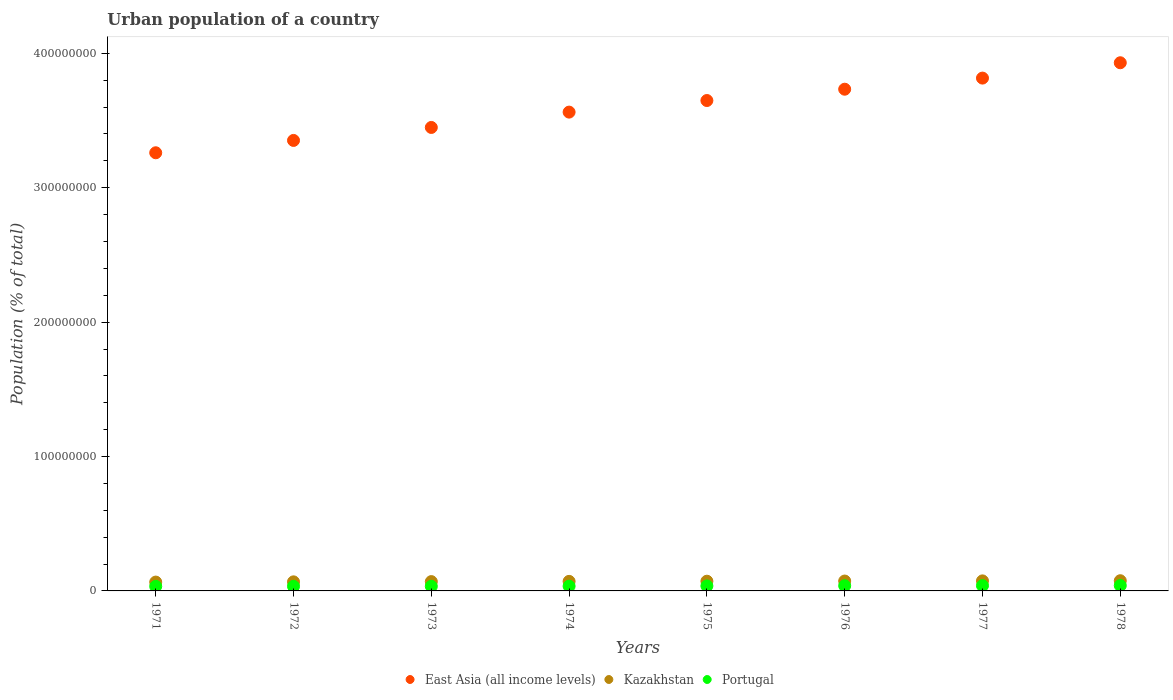How many different coloured dotlines are there?
Give a very brief answer. 3. Is the number of dotlines equal to the number of legend labels?
Your answer should be compact. Yes. What is the urban population in Kazakhstan in 1974?
Provide a succinct answer. 7.10e+06. Across all years, what is the maximum urban population in East Asia (all income levels)?
Provide a succinct answer. 3.93e+08. Across all years, what is the minimum urban population in East Asia (all income levels)?
Provide a short and direct response. 3.26e+08. In which year was the urban population in Kazakhstan maximum?
Offer a very short reply. 1978. In which year was the urban population in East Asia (all income levels) minimum?
Your answer should be compact. 1971. What is the total urban population in East Asia (all income levels) in the graph?
Your answer should be very brief. 2.88e+09. What is the difference between the urban population in Kazakhstan in 1973 and that in 1975?
Provide a succinct answer. -3.01e+05. What is the difference between the urban population in Kazakhstan in 1975 and the urban population in East Asia (all income levels) in 1977?
Make the answer very short. -3.74e+08. What is the average urban population in East Asia (all income levels) per year?
Provide a succinct answer. 3.59e+08. In the year 1972, what is the difference between the urban population in East Asia (all income levels) and urban population in Portugal?
Provide a succinct answer. 3.32e+08. In how many years, is the urban population in Kazakhstan greater than 180000000 %?
Keep it short and to the point. 0. What is the ratio of the urban population in Portugal in 1974 to that in 1976?
Your response must be concise. 0.92. Is the urban population in Portugal in 1974 less than that in 1977?
Provide a short and direct response. Yes. Is the difference between the urban population in East Asia (all income levels) in 1975 and 1977 greater than the difference between the urban population in Portugal in 1975 and 1977?
Your response must be concise. No. What is the difference between the highest and the second highest urban population in Portugal?
Your response must be concise. 8.10e+04. What is the difference between the highest and the lowest urban population in Portugal?
Provide a short and direct response. 6.24e+05. In how many years, is the urban population in East Asia (all income levels) greater than the average urban population in East Asia (all income levels) taken over all years?
Offer a very short reply. 4. Is the sum of the urban population in East Asia (all income levels) in 1972 and 1976 greater than the maximum urban population in Portugal across all years?
Provide a succinct answer. Yes. Does the urban population in Kazakhstan monotonically increase over the years?
Give a very brief answer. Yes. Is the urban population in East Asia (all income levels) strictly less than the urban population in Portugal over the years?
Your answer should be very brief. No. How many dotlines are there?
Give a very brief answer. 3. Are the values on the major ticks of Y-axis written in scientific E-notation?
Your answer should be very brief. No. Does the graph contain any zero values?
Offer a very short reply. No. Where does the legend appear in the graph?
Your answer should be very brief. Bottom center. How many legend labels are there?
Offer a very short reply. 3. How are the legend labels stacked?
Provide a succinct answer. Horizontal. What is the title of the graph?
Keep it short and to the point. Urban population of a country. What is the label or title of the Y-axis?
Keep it short and to the point. Population (% of total). What is the Population (% of total) of East Asia (all income levels) in 1971?
Your response must be concise. 3.26e+08. What is the Population (% of total) of Kazakhstan in 1971?
Make the answer very short. 6.58e+06. What is the Population (% of total) in Portugal in 1971?
Provide a succinct answer. 3.39e+06. What is the Population (% of total) of East Asia (all income levels) in 1972?
Your answer should be very brief. 3.35e+08. What is the Population (% of total) of Kazakhstan in 1972?
Make the answer very short. 6.76e+06. What is the Population (% of total) of Portugal in 1972?
Make the answer very short. 3.42e+06. What is the Population (% of total) of East Asia (all income levels) in 1973?
Your answer should be very brief. 3.45e+08. What is the Population (% of total) of Kazakhstan in 1973?
Offer a very short reply. 6.93e+06. What is the Population (% of total) of Portugal in 1973?
Make the answer very short. 3.45e+06. What is the Population (% of total) of East Asia (all income levels) in 1974?
Ensure brevity in your answer.  3.56e+08. What is the Population (% of total) in Kazakhstan in 1974?
Your answer should be compact. 7.10e+06. What is the Population (% of total) of Portugal in 1974?
Your response must be concise. 3.54e+06. What is the Population (% of total) of East Asia (all income levels) in 1975?
Your answer should be compact. 3.65e+08. What is the Population (% of total) of Kazakhstan in 1975?
Your answer should be very brief. 7.23e+06. What is the Population (% of total) of Portugal in 1975?
Provide a succinct answer. 3.71e+06. What is the Population (% of total) in East Asia (all income levels) in 1976?
Your answer should be very brief. 3.73e+08. What is the Population (% of total) in Kazakhstan in 1976?
Your answer should be compact. 7.35e+06. What is the Population (% of total) of Portugal in 1976?
Your response must be concise. 3.85e+06. What is the Population (% of total) of East Asia (all income levels) in 1977?
Give a very brief answer. 3.82e+08. What is the Population (% of total) of Kazakhstan in 1977?
Keep it short and to the point. 7.47e+06. What is the Population (% of total) of Portugal in 1977?
Offer a very short reply. 3.93e+06. What is the Population (% of total) in East Asia (all income levels) in 1978?
Your answer should be very brief. 3.93e+08. What is the Population (% of total) of Kazakhstan in 1978?
Make the answer very short. 7.58e+06. What is the Population (% of total) in Portugal in 1978?
Your answer should be very brief. 4.01e+06. Across all years, what is the maximum Population (% of total) in East Asia (all income levels)?
Offer a very short reply. 3.93e+08. Across all years, what is the maximum Population (% of total) of Kazakhstan?
Provide a short and direct response. 7.58e+06. Across all years, what is the maximum Population (% of total) in Portugal?
Give a very brief answer. 4.01e+06. Across all years, what is the minimum Population (% of total) of East Asia (all income levels)?
Ensure brevity in your answer.  3.26e+08. Across all years, what is the minimum Population (% of total) in Kazakhstan?
Offer a terse response. 6.58e+06. Across all years, what is the minimum Population (% of total) in Portugal?
Give a very brief answer. 3.39e+06. What is the total Population (% of total) of East Asia (all income levels) in the graph?
Give a very brief answer. 2.88e+09. What is the total Population (% of total) in Kazakhstan in the graph?
Provide a succinct answer. 5.70e+07. What is the total Population (% of total) in Portugal in the graph?
Your response must be concise. 2.93e+07. What is the difference between the Population (% of total) in East Asia (all income levels) in 1971 and that in 1972?
Give a very brief answer. -9.18e+06. What is the difference between the Population (% of total) in Kazakhstan in 1971 and that in 1972?
Your answer should be very brief. -1.74e+05. What is the difference between the Population (% of total) of Portugal in 1971 and that in 1972?
Ensure brevity in your answer.  -2.88e+04. What is the difference between the Population (% of total) in East Asia (all income levels) in 1971 and that in 1973?
Your answer should be compact. -1.88e+07. What is the difference between the Population (% of total) in Kazakhstan in 1971 and that in 1973?
Your answer should be compact. -3.49e+05. What is the difference between the Population (% of total) of Portugal in 1971 and that in 1973?
Provide a succinct answer. -6.39e+04. What is the difference between the Population (% of total) in East Asia (all income levels) in 1971 and that in 1974?
Your answer should be compact. -3.03e+07. What is the difference between the Population (% of total) in Kazakhstan in 1971 and that in 1974?
Your answer should be very brief. -5.20e+05. What is the difference between the Population (% of total) in Portugal in 1971 and that in 1974?
Your answer should be compact. -1.47e+05. What is the difference between the Population (% of total) in East Asia (all income levels) in 1971 and that in 1975?
Make the answer very short. -3.89e+07. What is the difference between the Population (% of total) of Kazakhstan in 1971 and that in 1975?
Your answer should be very brief. -6.50e+05. What is the difference between the Population (% of total) in Portugal in 1971 and that in 1975?
Provide a short and direct response. -3.20e+05. What is the difference between the Population (% of total) in East Asia (all income levels) in 1971 and that in 1976?
Your answer should be very brief. -4.73e+07. What is the difference between the Population (% of total) in Kazakhstan in 1971 and that in 1976?
Provide a succinct answer. -7.73e+05. What is the difference between the Population (% of total) in Portugal in 1971 and that in 1976?
Your answer should be compact. -4.65e+05. What is the difference between the Population (% of total) in East Asia (all income levels) in 1971 and that in 1977?
Give a very brief answer. -5.56e+07. What is the difference between the Population (% of total) in Kazakhstan in 1971 and that in 1977?
Make the answer very short. -8.89e+05. What is the difference between the Population (% of total) of Portugal in 1971 and that in 1977?
Provide a succinct answer. -5.43e+05. What is the difference between the Population (% of total) in East Asia (all income levels) in 1971 and that in 1978?
Your answer should be very brief. -6.70e+07. What is the difference between the Population (% of total) of Kazakhstan in 1971 and that in 1978?
Offer a very short reply. -1.00e+06. What is the difference between the Population (% of total) of Portugal in 1971 and that in 1978?
Ensure brevity in your answer.  -6.24e+05. What is the difference between the Population (% of total) of East Asia (all income levels) in 1972 and that in 1973?
Keep it short and to the point. -9.66e+06. What is the difference between the Population (% of total) of Kazakhstan in 1972 and that in 1973?
Your answer should be very brief. -1.74e+05. What is the difference between the Population (% of total) in Portugal in 1972 and that in 1973?
Keep it short and to the point. -3.51e+04. What is the difference between the Population (% of total) of East Asia (all income levels) in 1972 and that in 1974?
Offer a terse response. -2.11e+07. What is the difference between the Population (% of total) of Kazakhstan in 1972 and that in 1974?
Make the answer very short. -3.45e+05. What is the difference between the Population (% of total) of Portugal in 1972 and that in 1974?
Provide a short and direct response. -1.18e+05. What is the difference between the Population (% of total) of East Asia (all income levels) in 1972 and that in 1975?
Make the answer very short. -2.97e+07. What is the difference between the Population (% of total) of Kazakhstan in 1972 and that in 1975?
Offer a very short reply. -4.76e+05. What is the difference between the Population (% of total) of Portugal in 1972 and that in 1975?
Provide a short and direct response. -2.91e+05. What is the difference between the Population (% of total) of East Asia (all income levels) in 1972 and that in 1976?
Make the answer very short. -3.81e+07. What is the difference between the Population (% of total) in Kazakhstan in 1972 and that in 1976?
Keep it short and to the point. -5.98e+05. What is the difference between the Population (% of total) of Portugal in 1972 and that in 1976?
Offer a terse response. -4.36e+05. What is the difference between the Population (% of total) in East Asia (all income levels) in 1972 and that in 1977?
Your answer should be compact. -4.64e+07. What is the difference between the Population (% of total) of Kazakhstan in 1972 and that in 1977?
Make the answer very short. -7.15e+05. What is the difference between the Population (% of total) of Portugal in 1972 and that in 1977?
Ensure brevity in your answer.  -5.15e+05. What is the difference between the Population (% of total) in East Asia (all income levels) in 1972 and that in 1978?
Give a very brief answer. -5.78e+07. What is the difference between the Population (% of total) in Kazakhstan in 1972 and that in 1978?
Your response must be concise. -8.29e+05. What is the difference between the Population (% of total) of Portugal in 1972 and that in 1978?
Provide a short and direct response. -5.96e+05. What is the difference between the Population (% of total) in East Asia (all income levels) in 1973 and that in 1974?
Provide a succinct answer. -1.14e+07. What is the difference between the Population (% of total) in Kazakhstan in 1973 and that in 1974?
Offer a terse response. -1.71e+05. What is the difference between the Population (% of total) in Portugal in 1973 and that in 1974?
Your response must be concise. -8.32e+04. What is the difference between the Population (% of total) of East Asia (all income levels) in 1973 and that in 1975?
Your response must be concise. -2.00e+07. What is the difference between the Population (% of total) of Kazakhstan in 1973 and that in 1975?
Your response must be concise. -3.01e+05. What is the difference between the Population (% of total) of Portugal in 1973 and that in 1975?
Provide a succinct answer. -2.56e+05. What is the difference between the Population (% of total) in East Asia (all income levels) in 1973 and that in 1976?
Provide a succinct answer. -2.85e+07. What is the difference between the Population (% of total) of Kazakhstan in 1973 and that in 1976?
Give a very brief answer. -4.24e+05. What is the difference between the Population (% of total) of Portugal in 1973 and that in 1976?
Make the answer very short. -4.01e+05. What is the difference between the Population (% of total) in East Asia (all income levels) in 1973 and that in 1977?
Your answer should be very brief. -3.67e+07. What is the difference between the Population (% of total) in Kazakhstan in 1973 and that in 1977?
Offer a terse response. -5.40e+05. What is the difference between the Population (% of total) of Portugal in 1973 and that in 1977?
Your answer should be very brief. -4.80e+05. What is the difference between the Population (% of total) in East Asia (all income levels) in 1973 and that in 1978?
Your response must be concise. -4.81e+07. What is the difference between the Population (% of total) in Kazakhstan in 1973 and that in 1978?
Give a very brief answer. -6.55e+05. What is the difference between the Population (% of total) in Portugal in 1973 and that in 1978?
Your answer should be compact. -5.61e+05. What is the difference between the Population (% of total) in East Asia (all income levels) in 1974 and that in 1975?
Offer a terse response. -8.62e+06. What is the difference between the Population (% of total) in Kazakhstan in 1974 and that in 1975?
Offer a terse response. -1.30e+05. What is the difference between the Population (% of total) of Portugal in 1974 and that in 1975?
Keep it short and to the point. -1.73e+05. What is the difference between the Population (% of total) in East Asia (all income levels) in 1974 and that in 1976?
Your answer should be very brief. -1.70e+07. What is the difference between the Population (% of total) of Kazakhstan in 1974 and that in 1976?
Offer a very short reply. -2.53e+05. What is the difference between the Population (% of total) in Portugal in 1974 and that in 1976?
Ensure brevity in your answer.  -3.17e+05. What is the difference between the Population (% of total) in East Asia (all income levels) in 1974 and that in 1977?
Your response must be concise. -2.53e+07. What is the difference between the Population (% of total) of Kazakhstan in 1974 and that in 1977?
Ensure brevity in your answer.  -3.70e+05. What is the difference between the Population (% of total) in Portugal in 1974 and that in 1977?
Provide a short and direct response. -3.96e+05. What is the difference between the Population (% of total) in East Asia (all income levels) in 1974 and that in 1978?
Give a very brief answer. -3.67e+07. What is the difference between the Population (% of total) in Kazakhstan in 1974 and that in 1978?
Offer a terse response. -4.84e+05. What is the difference between the Population (% of total) in Portugal in 1974 and that in 1978?
Offer a very short reply. -4.77e+05. What is the difference between the Population (% of total) in East Asia (all income levels) in 1975 and that in 1976?
Ensure brevity in your answer.  -8.42e+06. What is the difference between the Population (% of total) of Kazakhstan in 1975 and that in 1976?
Your answer should be compact. -1.23e+05. What is the difference between the Population (% of total) of Portugal in 1975 and that in 1976?
Ensure brevity in your answer.  -1.44e+05. What is the difference between the Population (% of total) in East Asia (all income levels) in 1975 and that in 1977?
Provide a succinct answer. -1.67e+07. What is the difference between the Population (% of total) of Kazakhstan in 1975 and that in 1977?
Offer a very short reply. -2.39e+05. What is the difference between the Population (% of total) in Portugal in 1975 and that in 1977?
Offer a terse response. -2.23e+05. What is the difference between the Population (% of total) in East Asia (all income levels) in 1975 and that in 1978?
Ensure brevity in your answer.  -2.81e+07. What is the difference between the Population (% of total) in Kazakhstan in 1975 and that in 1978?
Your response must be concise. -3.53e+05. What is the difference between the Population (% of total) in Portugal in 1975 and that in 1978?
Your answer should be compact. -3.04e+05. What is the difference between the Population (% of total) in East Asia (all income levels) in 1976 and that in 1977?
Ensure brevity in your answer.  -8.27e+06. What is the difference between the Population (% of total) in Kazakhstan in 1976 and that in 1977?
Keep it short and to the point. -1.17e+05. What is the difference between the Population (% of total) of Portugal in 1976 and that in 1977?
Make the answer very short. -7.89e+04. What is the difference between the Population (% of total) of East Asia (all income levels) in 1976 and that in 1978?
Ensure brevity in your answer.  -1.97e+07. What is the difference between the Population (% of total) of Kazakhstan in 1976 and that in 1978?
Keep it short and to the point. -2.31e+05. What is the difference between the Population (% of total) of Portugal in 1976 and that in 1978?
Provide a succinct answer. -1.60e+05. What is the difference between the Population (% of total) of East Asia (all income levels) in 1977 and that in 1978?
Ensure brevity in your answer.  -1.14e+07. What is the difference between the Population (% of total) of Kazakhstan in 1977 and that in 1978?
Provide a short and direct response. -1.14e+05. What is the difference between the Population (% of total) of Portugal in 1977 and that in 1978?
Your answer should be very brief. -8.10e+04. What is the difference between the Population (% of total) of East Asia (all income levels) in 1971 and the Population (% of total) of Kazakhstan in 1972?
Offer a terse response. 3.19e+08. What is the difference between the Population (% of total) in East Asia (all income levels) in 1971 and the Population (% of total) in Portugal in 1972?
Offer a very short reply. 3.23e+08. What is the difference between the Population (% of total) in Kazakhstan in 1971 and the Population (% of total) in Portugal in 1972?
Your response must be concise. 3.16e+06. What is the difference between the Population (% of total) of East Asia (all income levels) in 1971 and the Population (% of total) of Kazakhstan in 1973?
Keep it short and to the point. 3.19e+08. What is the difference between the Population (% of total) in East Asia (all income levels) in 1971 and the Population (% of total) in Portugal in 1973?
Your answer should be very brief. 3.23e+08. What is the difference between the Population (% of total) in Kazakhstan in 1971 and the Population (% of total) in Portugal in 1973?
Your answer should be very brief. 3.13e+06. What is the difference between the Population (% of total) in East Asia (all income levels) in 1971 and the Population (% of total) in Kazakhstan in 1974?
Provide a short and direct response. 3.19e+08. What is the difference between the Population (% of total) of East Asia (all income levels) in 1971 and the Population (% of total) of Portugal in 1974?
Make the answer very short. 3.22e+08. What is the difference between the Population (% of total) of Kazakhstan in 1971 and the Population (% of total) of Portugal in 1974?
Your answer should be compact. 3.05e+06. What is the difference between the Population (% of total) in East Asia (all income levels) in 1971 and the Population (% of total) in Kazakhstan in 1975?
Offer a terse response. 3.19e+08. What is the difference between the Population (% of total) of East Asia (all income levels) in 1971 and the Population (% of total) of Portugal in 1975?
Ensure brevity in your answer.  3.22e+08. What is the difference between the Population (% of total) of Kazakhstan in 1971 and the Population (% of total) of Portugal in 1975?
Your answer should be compact. 2.87e+06. What is the difference between the Population (% of total) of East Asia (all income levels) in 1971 and the Population (% of total) of Kazakhstan in 1976?
Your answer should be compact. 3.19e+08. What is the difference between the Population (% of total) of East Asia (all income levels) in 1971 and the Population (% of total) of Portugal in 1976?
Make the answer very short. 3.22e+08. What is the difference between the Population (% of total) in Kazakhstan in 1971 and the Population (% of total) in Portugal in 1976?
Make the answer very short. 2.73e+06. What is the difference between the Population (% of total) in East Asia (all income levels) in 1971 and the Population (% of total) in Kazakhstan in 1977?
Offer a very short reply. 3.19e+08. What is the difference between the Population (% of total) of East Asia (all income levels) in 1971 and the Population (% of total) of Portugal in 1977?
Make the answer very short. 3.22e+08. What is the difference between the Population (% of total) in Kazakhstan in 1971 and the Population (% of total) in Portugal in 1977?
Keep it short and to the point. 2.65e+06. What is the difference between the Population (% of total) in East Asia (all income levels) in 1971 and the Population (% of total) in Kazakhstan in 1978?
Give a very brief answer. 3.18e+08. What is the difference between the Population (% of total) of East Asia (all income levels) in 1971 and the Population (% of total) of Portugal in 1978?
Make the answer very short. 3.22e+08. What is the difference between the Population (% of total) of Kazakhstan in 1971 and the Population (% of total) of Portugal in 1978?
Provide a succinct answer. 2.57e+06. What is the difference between the Population (% of total) in East Asia (all income levels) in 1972 and the Population (% of total) in Kazakhstan in 1973?
Your response must be concise. 3.28e+08. What is the difference between the Population (% of total) in East Asia (all income levels) in 1972 and the Population (% of total) in Portugal in 1973?
Make the answer very short. 3.32e+08. What is the difference between the Population (% of total) in Kazakhstan in 1972 and the Population (% of total) in Portugal in 1973?
Keep it short and to the point. 3.30e+06. What is the difference between the Population (% of total) of East Asia (all income levels) in 1972 and the Population (% of total) of Kazakhstan in 1974?
Give a very brief answer. 3.28e+08. What is the difference between the Population (% of total) in East Asia (all income levels) in 1972 and the Population (% of total) in Portugal in 1974?
Provide a succinct answer. 3.32e+08. What is the difference between the Population (% of total) in Kazakhstan in 1972 and the Population (% of total) in Portugal in 1974?
Offer a terse response. 3.22e+06. What is the difference between the Population (% of total) in East Asia (all income levels) in 1972 and the Population (% of total) in Kazakhstan in 1975?
Provide a short and direct response. 3.28e+08. What is the difference between the Population (% of total) of East Asia (all income levels) in 1972 and the Population (% of total) of Portugal in 1975?
Offer a very short reply. 3.31e+08. What is the difference between the Population (% of total) in Kazakhstan in 1972 and the Population (% of total) in Portugal in 1975?
Your response must be concise. 3.05e+06. What is the difference between the Population (% of total) in East Asia (all income levels) in 1972 and the Population (% of total) in Kazakhstan in 1976?
Ensure brevity in your answer.  3.28e+08. What is the difference between the Population (% of total) in East Asia (all income levels) in 1972 and the Population (% of total) in Portugal in 1976?
Provide a short and direct response. 3.31e+08. What is the difference between the Population (% of total) in Kazakhstan in 1972 and the Population (% of total) in Portugal in 1976?
Your answer should be very brief. 2.90e+06. What is the difference between the Population (% of total) of East Asia (all income levels) in 1972 and the Population (% of total) of Kazakhstan in 1977?
Your answer should be very brief. 3.28e+08. What is the difference between the Population (% of total) of East Asia (all income levels) in 1972 and the Population (% of total) of Portugal in 1977?
Keep it short and to the point. 3.31e+08. What is the difference between the Population (% of total) of Kazakhstan in 1972 and the Population (% of total) of Portugal in 1977?
Provide a succinct answer. 2.82e+06. What is the difference between the Population (% of total) of East Asia (all income levels) in 1972 and the Population (% of total) of Kazakhstan in 1978?
Offer a very short reply. 3.28e+08. What is the difference between the Population (% of total) of East Asia (all income levels) in 1972 and the Population (% of total) of Portugal in 1978?
Provide a succinct answer. 3.31e+08. What is the difference between the Population (% of total) of Kazakhstan in 1972 and the Population (% of total) of Portugal in 1978?
Make the answer very short. 2.74e+06. What is the difference between the Population (% of total) of East Asia (all income levels) in 1973 and the Population (% of total) of Kazakhstan in 1974?
Make the answer very short. 3.38e+08. What is the difference between the Population (% of total) of East Asia (all income levels) in 1973 and the Population (% of total) of Portugal in 1974?
Offer a terse response. 3.41e+08. What is the difference between the Population (% of total) in Kazakhstan in 1973 and the Population (% of total) in Portugal in 1974?
Ensure brevity in your answer.  3.39e+06. What is the difference between the Population (% of total) in East Asia (all income levels) in 1973 and the Population (% of total) in Kazakhstan in 1975?
Keep it short and to the point. 3.38e+08. What is the difference between the Population (% of total) of East Asia (all income levels) in 1973 and the Population (% of total) of Portugal in 1975?
Keep it short and to the point. 3.41e+08. What is the difference between the Population (% of total) in Kazakhstan in 1973 and the Population (% of total) in Portugal in 1975?
Ensure brevity in your answer.  3.22e+06. What is the difference between the Population (% of total) in East Asia (all income levels) in 1973 and the Population (% of total) in Kazakhstan in 1976?
Your answer should be very brief. 3.38e+08. What is the difference between the Population (% of total) of East Asia (all income levels) in 1973 and the Population (% of total) of Portugal in 1976?
Your answer should be compact. 3.41e+08. What is the difference between the Population (% of total) of Kazakhstan in 1973 and the Population (% of total) of Portugal in 1976?
Ensure brevity in your answer.  3.08e+06. What is the difference between the Population (% of total) of East Asia (all income levels) in 1973 and the Population (% of total) of Kazakhstan in 1977?
Make the answer very short. 3.37e+08. What is the difference between the Population (% of total) in East Asia (all income levels) in 1973 and the Population (% of total) in Portugal in 1977?
Your response must be concise. 3.41e+08. What is the difference between the Population (% of total) in Kazakhstan in 1973 and the Population (% of total) in Portugal in 1977?
Offer a very short reply. 3.00e+06. What is the difference between the Population (% of total) of East Asia (all income levels) in 1973 and the Population (% of total) of Kazakhstan in 1978?
Provide a short and direct response. 3.37e+08. What is the difference between the Population (% of total) in East Asia (all income levels) in 1973 and the Population (% of total) in Portugal in 1978?
Your answer should be very brief. 3.41e+08. What is the difference between the Population (% of total) of Kazakhstan in 1973 and the Population (% of total) of Portugal in 1978?
Provide a short and direct response. 2.92e+06. What is the difference between the Population (% of total) in East Asia (all income levels) in 1974 and the Population (% of total) in Kazakhstan in 1975?
Provide a succinct answer. 3.49e+08. What is the difference between the Population (% of total) in East Asia (all income levels) in 1974 and the Population (% of total) in Portugal in 1975?
Make the answer very short. 3.53e+08. What is the difference between the Population (% of total) in Kazakhstan in 1974 and the Population (% of total) in Portugal in 1975?
Offer a very short reply. 3.39e+06. What is the difference between the Population (% of total) of East Asia (all income levels) in 1974 and the Population (% of total) of Kazakhstan in 1976?
Provide a succinct answer. 3.49e+08. What is the difference between the Population (% of total) of East Asia (all income levels) in 1974 and the Population (% of total) of Portugal in 1976?
Make the answer very short. 3.52e+08. What is the difference between the Population (% of total) of Kazakhstan in 1974 and the Population (% of total) of Portugal in 1976?
Your answer should be compact. 3.25e+06. What is the difference between the Population (% of total) of East Asia (all income levels) in 1974 and the Population (% of total) of Kazakhstan in 1977?
Your answer should be very brief. 3.49e+08. What is the difference between the Population (% of total) of East Asia (all income levels) in 1974 and the Population (% of total) of Portugal in 1977?
Provide a succinct answer. 3.52e+08. What is the difference between the Population (% of total) of Kazakhstan in 1974 and the Population (% of total) of Portugal in 1977?
Provide a succinct answer. 3.17e+06. What is the difference between the Population (% of total) in East Asia (all income levels) in 1974 and the Population (% of total) in Kazakhstan in 1978?
Provide a short and direct response. 3.49e+08. What is the difference between the Population (% of total) in East Asia (all income levels) in 1974 and the Population (% of total) in Portugal in 1978?
Your response must be concise. 3.52e+08. What is the difference between the Population (% of total) in Kazakhstan in 1974 and the Population (% of total) in Portugal in 1978?
Offer a terse response. 3.09e+06. What is the difference between the Population (% of total) in East Asia (all income levels) in 1975 and the Population (% of total) in Kazakhstan in 1976?
Your answer should be compact. 3.58e+08. What is the difference between the Population (% of total) in East Asia (all income levels) in 1975 and the Population (% of total) in Portugal in 1976?
Give a very brief answer. 3.61e+08. What is the difference between the Population (% of total) of Kazakhstan in 1975 and the Population (% of total) of Portugal in 1976?
Your answer should be very brief. 3.38e+06. What is the difference between the Population (% of total) of East Asia (all income levels) in 1975 and the Population (% of total) of Kazakhstan in 1977?
Your response must be concise. 3.57e+08. What is the difference between the Population (% of total) in East Asia (all income levels) in 1975 and the Population (% of total) in Portugal in 1977?
Give a very brief answer. 3.61e+08. What is the difference between the Population (% of total) of Kazakhstan in 1975 and the Population (% of total) of Portugal in 1977?
Keep it short and to the point. 3.30e+06. What is the difference between the Population (% of total) in East Asia (all income levels) in 1975 and the Population (% of total) in Kazakhstan in 1978?
Give a very brief answer. 3.57e+08. What is the difference between the Population (% of total) in East Asia (all income levels) in 1975 and the Population (% of total) in Portugal in 1978?
Keep it short and to the point. 3.61e+08. What is the difference between the Population (% of total) of Kazakhstan in 1975 and the Population (% of total) of Portugal in 1978?
Ensure brevity in your answer.  3.22e+06. What is the difference between the Population (% of total) of East Asia (all income levels) in 1976 and the Population (% of total) of Kazakhstan in 1977?
Your response must be concise. 3.66e+08. What is the difference between the Population (% of total) of East Asia (all income levels) in 1976 and the Population (% of total) of Portugal in 1977?
Make the answer very short. 3.69e+08. What is the difference between the Population (% of total) in Kazakhstan in 1976 and the Population (% of total) in Portugal in 1977?
Offer a terse response. 3.42e+06. What is the difference between the Population (% of total) in East Asia (all income levels) in 1976 and the Population (% of total) in Kazakhstan in 1978?
Your answer should be very brief. 3.66e+08. What is the difference between the Population (% of total) in East Asia (all income levels) in 1976 and the Population (% of total) in Portugal in 1978?
Your answer should be very brief. 3.69e+08. What is the difference between the Population (% of total) in Kazakhstan in 1976 and the Population (% of total) in Portugal in 1978?
Make the answer very short. 3.34e+06. What is the difference between the Population (% of total) in East Asia (all income levels) in 1977 and the Population (% of total) in Kazakhstan in 1978?
Your answer should be very brief. 3.74e+08. What is the difference between the Population (% of total) in East Asia (all income levels) in 1977 and the Population (% of total) in Portugal in 1978?
Make the answer very short. 3.78e+08. What is the difference between the Population (% of total) in Kazakhstan in 1977 and the Population (% of total) in Portugal in 1978?
Provide a succinct answer. 3.46e+06. What is the average Population (% of total) in East Asia (all income levels) per year?
Ensure brevity in your answer.  3.59e+08. What is the average Population (% of total) in Kazakhstan per year?
Provide a short and direct response. 7.13e+06. What is the average Population (% of total) in Portugal per year?
Your answer should be very brief. 3.66e+06. In the year 1971, what is the difference between the Population (% of total) in East Asia (all income levels) and Population (% of total) in Kazakhstan?
Your answer should be compact. 3.19e+08. In the year 1971, what is the difference between the Population (% of total) of East Asia (all income levels) and Population (% of total) of Portugal?
Your response must be concise. 3.23e+08. In the year 1971, what is the difference between the Population (% of total) of Kazakhstan and Population (% of total) of Portugal?
Ensure brevity in your answer.  3.19e+06. In the year 1972, what is the difference between the Population (% of total) of East Asia (all income levels) and Population (% of total) of Kazakhstan?
Give a very brief answer. 3.28e+08. In the year 1972, what is the difference between the Population (% of total) in East Asia (all income levels) and Population (% of total) in Portugal?
Make the answer very short. 3.32e+08. In the year 1972, what is the difference between the Population (% of total) in Kazakhstan and Population (% of total) in Portugal?
Keep it short and to the point. 3.34e+06. In the year 1973, what is the difference between the Population (% of total) in East Asia (all income levels) and Population (% of total) in Kazakhstan?
Offer a very short reply. 3.38e+08. In the year 1973, what is the difference between the Population (% of total) of East Asia (all income levels) and Population (% of total) of Portugal?
Your answer should be compact. 3.41e+08. In the year 1973, what is the difference between the Population (% of total) of Kazakhstan and Population (% of total) of Portugal?
Your answer should be very brief. 3.48e+06. In the year 1974, what is the difference between the Population (% of total) in East Asia (all income levels) and Population (% of total) in Kazakhstan?
Give a very brief answer. 3.49e+08. In the year 1974, what is the difference between the Population (% of total) in East Asia (all income levels) and Population (% of total) in Portugal?
Your response must be concise. 3.53e+08. In the year 1974, what is the difference between the Population (% of total) in Kazakhstan and Population (% of total) in Portugal?
Your response must be concise. 3.57e+06. In the year 1975, what is the difference between the Population (% of total) in East Asia (all income levels) and Population (% of total) in Kazakhstan?
Ensure brevity in your answer.  3.58e+08. In the year 1975, what is the difference between the Population (% of total) in East Asia (all income levels) and Population (% of total) in Portugal?
Keep it short and to the point. 3.61e+08. In the year 1975, what is the difference between the Population (% of total) of Kazakhstan and Population (% of total) of Portugal?
Your answer should be very brief. 3.52e+06. In the year 1976, what is the difference between the Population (% of total) in East Asia (all income levels) and Population (% of total) in Kazakhstan?
Your response must be concise. 3.66e+08. In the year 1976, what is the difference between the Population (% of total) of East Asia (all income levels) and Population (% of total) of Portugal?
Your answer should be very brief. 3.69e+08. In the year 1976, what is the difference between the Population (% of total) of Kazakhstan and Population (% of total) of Portugal?
Offer a terse response. 3.50e+06. In the year 1977, what is the difference between the Population (% of total) in East Asia (all income levels) and Population (% of total) in Kazakhstan?
Give a very brief answer. 3.74e+08. In the year 1977, what is the difference between the Population (% of total) in East Asia (all income levels) and Population (% of total) in Portugal?
Ensure brevity in your answer.  3.78e+08. In the year 1977, what is the difference between the Population (% of total) in Kazakhstan and Population (% of total) in Portugal?
Your answer should be very brief. 3.54e+06. In the year 1978, what is the difference between the Population (% of total) of East Asia (all income levels) and Population (% of total) of Kazakhstan?
Offer a terse response. 3.85e+08. In the year 1978, what is the difference between the Population (% of total) of East Asia (all income levels) and Population (% of total) of Portugal?
Provide a succinct answer. 3.89e+08. In the year 1978, what is the difference between the Population (% of total) in Kazakhstan and Population (% of total) in Portugal?
Offer a terse response. 3.57e+06. What is the ratio of the Population (% of total) in East Asia (all income levels) in 1971 to that in 1972?
Keep it short and to the point. 0.97. What is the ratio of the Population (% of total) in Kazakhstan in 1971 to that in 1972?
Provide a short and direct response. 0.97. What is the ratio of the Population (% of total) in Portugal in 1971 to that in 1972?
Your answer should be very brief. 0.99. What is the ratio of the Population (% of total) in East Asia (all income levels) in 1971 to that in 1973?
Give a very brief answer. 0.95. What is the ratio of the Population (% of total) of Kazakhstan in 1971 to that in 1973?
Offer a terse response. 0.95. What is the ratio of the Population (% of total) of Portugal in 1971 to that in 1973?
Make the answer very short. 0.98. What is the ratio of the Population (% of total) of East Asia (all income levels) in 1971 to that in 1974?
Ensure brevity in your answer.  0.92. What is the ratio of the Population (% of total) in Kazakhstan in 1971 to that in 1974?
Offer a very short reply. 0.93. What is the ratio of the Population (% of total) in Portugal in 1971 to that in 1974?
Make the answer very short. 0.96. What is the ratio of the Population (% of total) of East Asia (all income levels) in 1971 to that in 1975?
Ensure brevity in your answer.  0.89. What is the ratio of the Population (% of total) of Kazakhstan in 1971 to that in 1975?
Offer a very short reply. 0.91. What is the ratio of the Population (% of total) in Portugal in 1971 to that in 1975?
Provide a short and direct response. 0.91. What is the ratio of the Population (% of total) of East Asia (all income levels) in 1971 to that in 1976?
Give a very brief answer. 0.87. What is the ratio of the Population (% of total) of Kazakhstan in 1971 to that in 1976?
Your answer should be very brief. 0.89. What is the ratio of the Population (% of total) of Portugal in 1971 to that in 1976?
Give a very brief answer. 0.88. What is the ratio of the Population (% of total) in East Asia (all income levels) in 1971 to that in 1977?
Provide a short and direct response. 0.85. What is the ratio of the Population (% of total) of Kazakhstan in 1971 to that in 1977?
Provide a succinct answer. 0.88. What is the ratio of the Population (% of total) in Portugal in 1971 to that in 1977?
Your response must be concise. 0.86. What is the ratio of the Population (% of total) of East Asia (all income levels) in 1971 to that in 1978?
Give a very brief answer. 0.83. What is the ratio of the Population (% of total) in Kazakhstan in 1971 to that in 1978?
Give a very brief answer. 0.87. What is the ratio of the Population (% of total) of Portugal in 1971 to that in 1978?
Provide a succinct answer. 0.84. What is the ratio of the Population (% of total) of East Asia (all income levels) in 1972 to that in 1973?
Your answer should be very brief. 0.97. What is the ratio of the Population (% of total) of Kazakhstan in 1972 to that in 1973?
Ensure brevity in your answer.  0.97. What is the ratio of the Population (% of total) in East Asia (all income levels) in 1972 to that in 1974?
Offer a terse response. 0.94. What is the ratio of the Population (% of total) of Kazakhstan in 1972 to that in 1974?
Give a very brief answer. 0.95. What is the ratio of the Population (% of total) of Portugal in 1972 to that in 1974?
Your answer should be compact. 0.97. What is the ratio of the Population (% of total) in East Asia (all income levels) in 1972 to that in 1975?
Give a very brief answer. 0.92. What is the ratio of the Population (% of total) of Kazakhstan in 1972 to that in 1975?
Keep it short and to the point. 0.93. What is the ratio of the Population (% of total) in Portugal in 1972 to that in 1975?
Make the answer very short. 0.92. What is the ratio of the Population (% of total) of East Asia (all income levels) in 1972 to that in 1976?
Provide a short and direct response. 0.9. What is the ratio of the Population (% of total) in Kazakhstan in 1972 to that in 1976?
Your response must be concise. 0.92. What is the ratio of the Population (% of total) in Portugal in 1972 to that in 1976?
Offer a very short reply. 0.89. What is the ratio of the Population (% of total) of East Asia (all income levels) in 1972 to that in 1977?
Give a very brief answer. 0.88. What is the ratio of the Population (% of total) of Kazakhstan in 1972 to that in 1977?
Provide a short and direct response. 0.9. What is the ratio of the Population (% of total) of Portugal in 1972 to that in 1977?
Offer a very short reply. 0.87. What is the ratio of the Population (% of total) of East Asia (all income levels) in 1972 to that in 1978?
Your answer should be very brief. 0.85. What is the ratio of the Population (% of total) in Kazakhstan in 1972 to that in 1978?
Your response must be concise. 0.89. What is the ratio of the Population (% of total) in Portugal in 1972 to that in 1978?
Your response must be concise. 0.85. What is the ratio of the Population (% of total) of Kazakhstan in 1973 to that in 1974?
Your response must be concise. 0.98. What is the ratio of the Population (% of total) of Portugal in 1973 to that in 1974?
Your answer should be compact. 0.98. What is the ratio of the Population (% of total) of East Asia (all income levels) in 1973 to that in 1975?
Your response must be concise. 0.95. What is the ratio of the Population (% of total) in Kazakhstan in 1973 to that in 1975?
Offer a terse response. 0.96. What is the ratio of the Population (% of total) of Portugal in 1973 to that in 1975?
Your response must be concise. 0.93. What is the ratio of the Population (% of total) in East Asia (all income levels) in 1973 to that in 1976?
Provide a short and direct response. 0.92. What is the ratio of the Population (% of total) in Kazakhstan in 1973 to that in 1976?
Provide a short and direct response. 0.94. What is the ratio of the Population (% of total) of Portugal in 1973 to that in 1976?
Your answer should be very brief. 0.9. What is the ratio of the Population (% of total) in East Asia (all income levels) in 1973 to that in 1977?
Your answer should be compact. 0.9. What is the ratio of the Population (% of total) in Kazakhstan in 1973 to that in 1977?
Offer a very short reply. 0.93. What is the ratio of the Population (% of total) in Portugal in 1973 to that in 1977?
Provide a short and direct response. 0.88. What is the ratio of the Population (% of total) in East Asia (all income levels) in 1973 to that in 1978?
Give a very brief answer. 0.88. What is the ratio of the Population (% of total) of Kazakhstan in 1973 to that in 1978?
Provide a succinct answer. 0.91. What is the ratio of the Population (% of total) in Portugal in 1973 to that in 1978?
Keep it short and to the point. 0.86. What is the ratio of the Population (% of total) in East Asia (all income levels) in 1974 to that in 1975?
Offer a very short reply. 0.98. What is the ratio of the Population (% of total) in Kazakhstan in 1974 to that in 1975?
Give a very brief answer. 0.98. What is the ratio of the Population (% of total) in Portugal in 1974 to that in 1975?
Give a very brief answer. 0.95. What is the ratio of the Population (% of total) of East Asia (all income levels) in 1974 to that in 1976?
Your response must be concise. 0.95. What is the ratio of the Population (% of total) in Kazakhstan in 1974 to that in 1976?
Offer a terse response. 0.97. What is the ratio of the Population (% of total) of Portugal in 1974 to that in 1976?
Make the answer very short. 0.92. What is the ratio of the Population (% of total) in East Asia (all income levels) in 1974 to that in 1977?
Your answer should be very brief. 0.93. What is the ratio of the Population (% of total) in Kazakhstan in 1974 to that in 1977?
Your answer should be compact. 0.95. What is the ratio of the Population (% of total) in Portugal in 1974 to that in 1977?
Your answer should be compact. 0.9. What is the ratio of the Population (% of total) of East Asia (all income levels) in 1974 to that in 1978?
Offer a very short reply. 0.91. What is the ratio of the Population (% of total) in Kazakhstan in 1974 to that in 1978?
Provide a short and direct response. 0.94. What is the ratio of the Population (% of total) in Portugal in 1974 to that in 1978?
Ensure brevity in your answer.  0.88. What is the ratio of the Population (% of total) of East Asia (all income levels) in 1975 to that in 1976?
Offer a terse response. 0.98. What is the ratio of the Population (% of total) in Kazakhstan in 1975 to that in 1976?
Your answer should be compact. 0.98. What is the ratio of the Population (% of total) in Portugal in 1975 to that in 1976?
Ensure brevity in your answer.  0.96. What is the ratio of the Population (% of total) in East Asia (all income levels) in 1975 to that in 1977?
Ensure brevity in your answer.  0.96. What is the ratio of the Population (% of total) in Portugal in 1975 to that in 1977?
Provide a succinct answer. 0.94. What is the ratio of the Population (% of total) in East Asia (all income levels) in 1975 to that in 1978?
Give a very brief answer. 0.93. What is the ratio of the Population (% of total) of Kazakhstan in 1975 to that in 1978?
Give a very brief answer. 0.95. What is the ratio of the Population (% of total) in Portugal in 1975 to that in 1978?
Provide a succinct answer. 0.92. What is the ratio of the Population (% of total) of East Asia (all income levels) in 1976 to that in 1977?
Make the answer very short. 0.98. What is the ratio of the Population (% of total) in Kazakhstan in 1976 to that in 1977?
Give a very brief answer. 0.98. What is the ratio of the Population (% of total) of Portugal in 1976 to that in 1977?
Make the answer very short. 0.98. What is the ratio of the Population (% of total) in East Asia (all income levels) in 1976 to that in 1978?
Your response must be concise. 0.95. What is the ratio of the Population (% of total) in Kazakhstan in 1976 to that in 1978?
Make the answer very short. 0.97. What is the ratio of the Population (% of total) in Portugal in 1976 to that in 1978?
Your answer should be compact. 0.96. What is the ratio of the Population (% of total) in East Asia (all income levels) in 1977 to that in 1978?
Ensure brevity in your answer.  0.97. What is the ratio of the Population (% of total) in Kazakhstan in 1977 to that in 1978?
Offer a terse response. 0.98. What is the ratio of the Population (% of total) in Portugal in 1977 to that in 1978?
Your answer should be compact. 0.98. What is the difference between the highest and the second highest Population (% of total) of East Asia (all income levels)?
Your answer should be compact. 1.14e+07. What is the difference between the highest and the second highest Population (% of total) of Kazakhstan?
Your answer should be compact. 1.14e+05. What is the difference between the highest and the second highest Population (% of total) of Portugal?
Offer a terse response. 8.10e+04. What is the difference between the highest and the lowest Population (% of total) in East Asia (all income levels)?
Give a very brief answer. 6.70e+07. What is the difference between the highest and the lowest Population (% of total) of Kazakhstan?
Make the answer very short. 1.00e+06. What is the difference between the highest and the lowest Population (% of total) of Portugal?
Provide a succinct answer. 6.24e+05. 